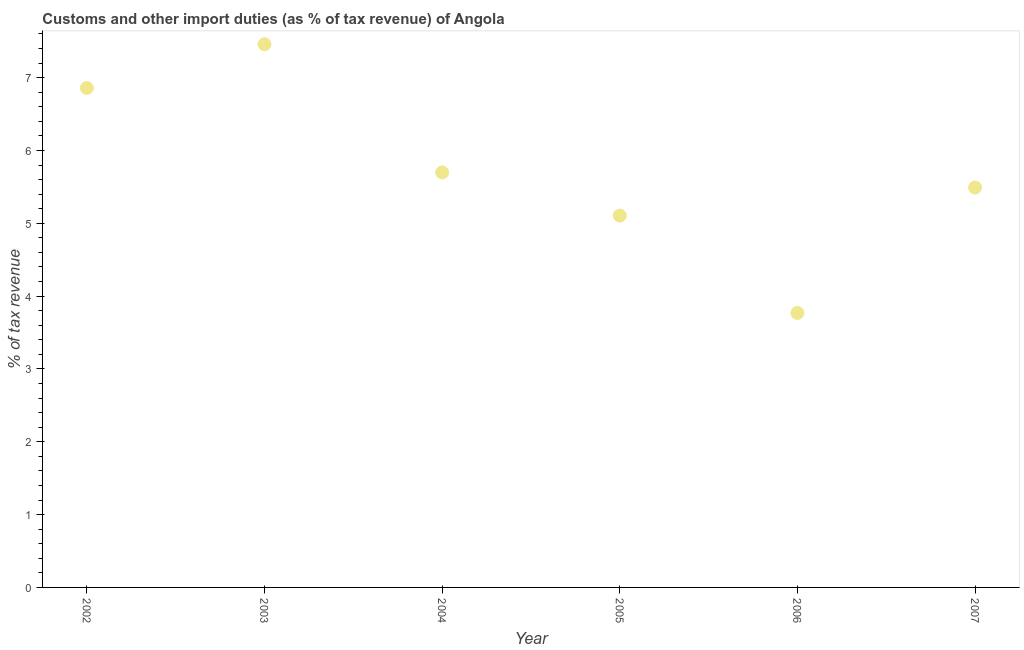What is the customs and other import duties in 2004?
Keep it short and to the point. 5.7. Across all years, what is the maximum customs and other import duties?
Give a very brief answer. 7.46. Across all years, what is the minimum customs and other import duties?
Your answer should be very brief. 3.77. In which year was the customs and other import duties minimum?
Give a very brief answer. 2006. What is the sum of the customs and other import duties?
Make the answer very short. 34.38. What is the difference between the customs and other import duties in 2002 and 2004?
Ensure brevity in your answer.  1.16. What is the average customs and other import duties per year?
Offer a very short reply. 5.73. What is the median customs and other import duties?
Give a very brief answer. 5.59. In how many years, is the customs and other import duties greater than 6 %?
Provide a short and direct response. 2. What is the ratio of the customs and other import duties in 2003 to that in 2004?
Provide a succinct answer. 1.31. What is the difference between the highest and the second highest customs and other import duties?
Your response must be concise. 0.6. Is the sum of the customs and other import duties in 2006 and 2007 greater than the maximum customs and other import duties across all years?
Your answer should be compact. Yes. What is the difference between the highest and the lowest customs and other import duties?
Offer a very short reply. 3.69. In how many years, is the customs and other import duties greater than the average customs and other import duties taken over all years?
Your answer should be very brief. 2. Does the customs and other import duties monotonically increase over the years?
Make the answer very short. No. How many dotlines are there?
Provide a succinct answer. 1. What is the difference between two consecutive major ticks on the Y-axis?
Provide a short and direct response. 1. Does the graph contain any zero values?
Provide a succinct answer. No. Does the graph contain grids?
Offer a very short reply. No. What is the title of the graph?
Make the answer very short. Customs and other import duties (as % of tax revenue) of Angola. What is the label or title of the Y-axis?
Keep it short and to the point. % of tax revenue. What is the % of tax revenue in 2002?
Give a very brief answer. 6.86. What is the % of tax revenue in 2003?
Give a very brief answer. 7.46. What is the % of tax revenue in 2004?
Your response must be concise. 5.7. What is the % of tax revenue in 2005?
Provide a short and direct response. 5.11. What is the % of tax revenue in 2006?
Ensure brevity in your answer.  3.77. What is the % of tax revenue in 2007?
Provide a succinct answer. 5.49. What is the difference between the % of tax revenue in 2002 and 2003?
Keep it short and to the point. -0.6. What is the difference between the % of tax revenue in 2002 and 2004?
Keep it short and to the point. 1.16. What is the difference between the % of tax revenue in 2002 and 2005?
Keep it short and to the point. 1.75. What is the difference between the % of tax revenue in 2002 and 2006?
Offer a terse response. 3.09. What is the difference between the % of tax revenue in 2002 and 2007?
Ensure brevity in your answer.  1.37. What is the difference between the % of tax revenue in 2003 and 2004?
Your response must be concise. 1.76. What is the difference between the % of tax revenue in 2003 and 2005?
Your answer should be compact. 2.35. What is the difference between the % of tax revenue in 2003 and 2006?
Your response must be concise. 3.69. What is the difference between the % of tax revenue in 2003 and 2007?
Keep it short and to the point. 1.97. What is the difference between the % of tax revenue in 2004 and 2005?
Your answer should be very brief. 0.59. What is the difference between the % of tax revenue in 2004 and 2006?
Ensure brevity in your answer.  1.93. What is the difference between the % of tax revenue in 2004 and 2007?
Provide a short and direct response. 0.21. What is the difference between the % of tax revenue in 2005 and 2006?
Your answer should be very brief. 1.34. What is the difference between the % of tax revenue in 2005 and 2007?
Your answer should be compact. -0.39. What is the difference between the % of tax revenue in 2006 and 2007?
Your answer should be very brief. -1.72. What is the ratio of the % of tax revenue in 2002 to that in 2004?
Provide a succinct answer. 1.2. What is the ratio of the % of tax revenue in 2002 to that in 2005?
Your response must be concise. 1.34. What is the ratio of the % of tax revenue in 2002 to that in 2006?
Keep it short and to the point. 1.82. What is the ratio of the % of tax revenue in 2002 to that in 2007?
Offer a very short reply. 1.25. What is the ratio of the % of tax revenue in 2003 to that in 2004?
Make the answer very short. 1.31. What is the ratio of the % of tax revenue in 2003 to that in 2005?
Offer a terse response. 1.46. What is the ratio of the % of tax revenue in 2003 to that in 2006?
Make the answer very short. 1.98. What is the ratio of the % of tax revenue in 2003 to that in 2007?
Make the answer very short. 1.36. What is the ratio of the % of tax revenue in 2004 to that in 2005?
Offer a very short reply. 1.12. What is the ratio of the % of tax revenue in 2004 to that in 2006?
Your answer should be compact. 1.51. What is the ratio of the % of tax revenue in 2004 to that in 2007?
Give a very brief answer. 1.04. What is the ratio of the % of tax revenue in 2005 to that in 2006?
Your answer should be compact. 1.35. What is the ratio of the % of tax revenue in 2006 to that in 2007?
Give a very brief answer. 0.69. 